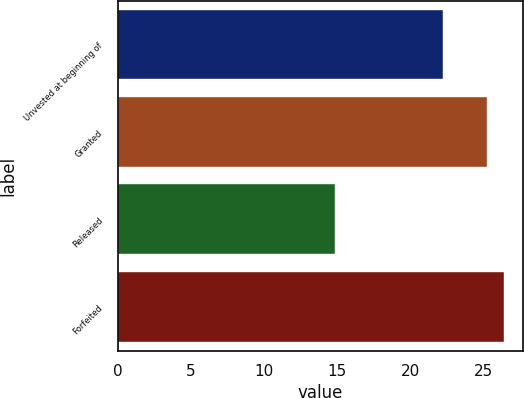Convert chart. <chart><loc_0><loc_0><loc_500><loc_500><bar_chart><fcel>Unvested at beginning of<fcel>Granted<fcel>Released<fcel>Forfeited<nl><fcel>22.2<fcel>25.26<fcel>14.88<fcel>26.41<nl></chart> 